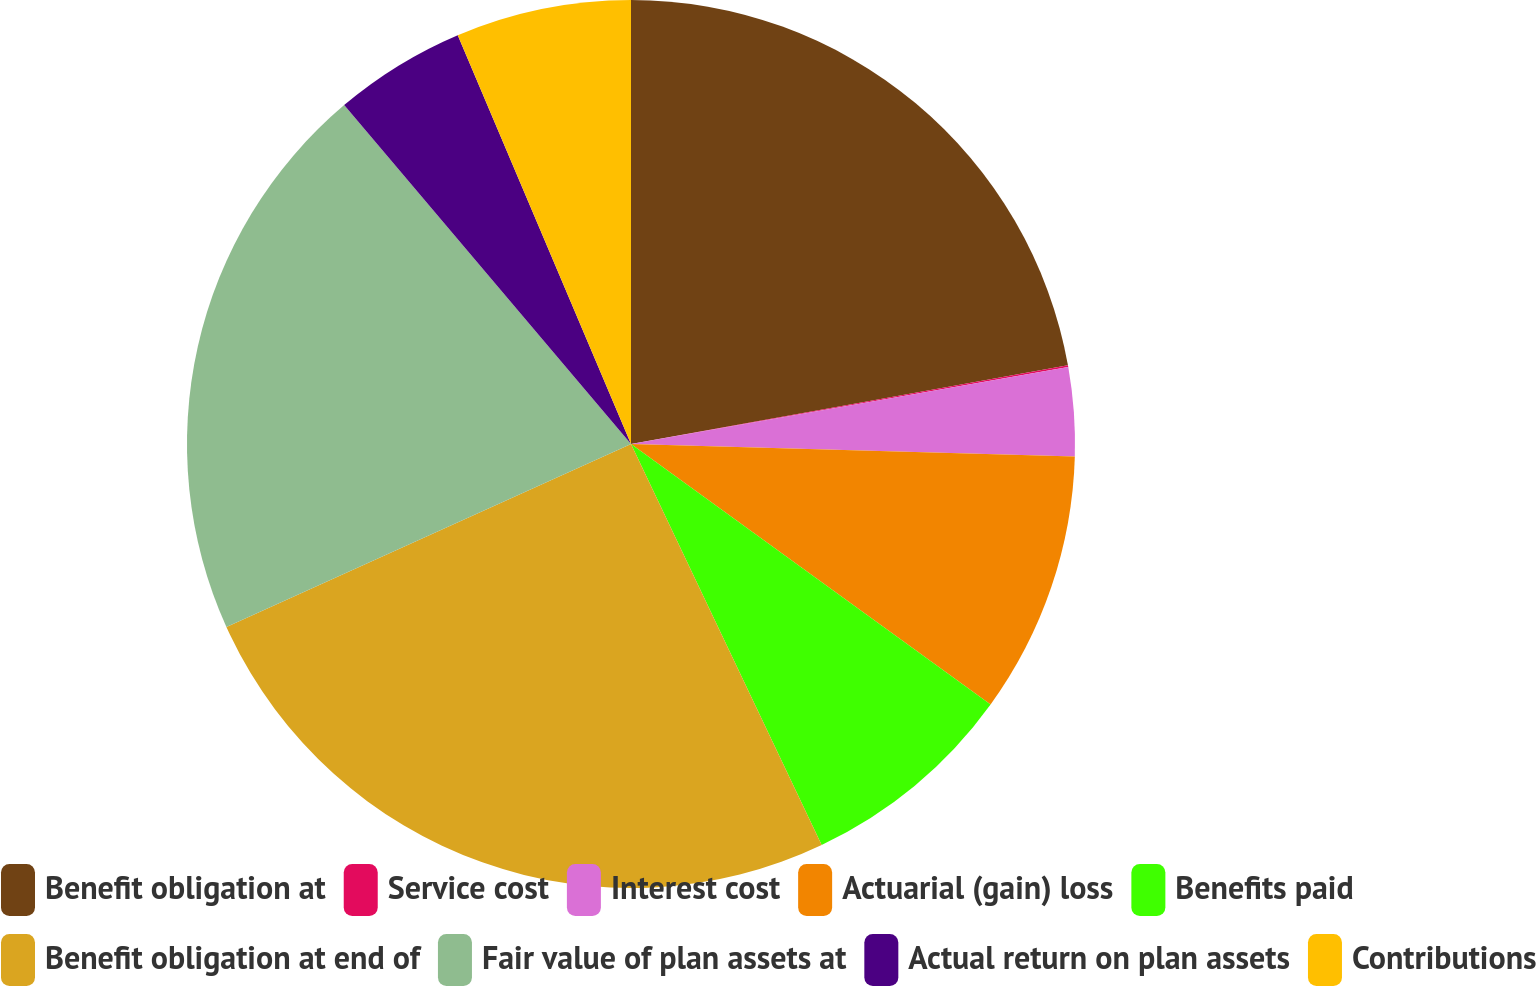<chart> <loc_0><loc_0><loc_500><loc_500><pie_chart><fcel>Benefit obligation at<fcel>Service cost<fcel>Interest cost<fcel>Actuarial (gain) loss<fcel>Benefits paid<fcel>Benefit obligation at end of<fcel>Fair value of plan assets at<fcel>Actual return on plan assets<fcel>Contributions<nl><fcel>22.16%<fcel>0.07%<fcel>3.22%<fcel>9.53%<fcel>7.96%<fcel>25.31%<fcel>20.58%<fcel>4.8%<fcel>6.38%<nl></chart> 